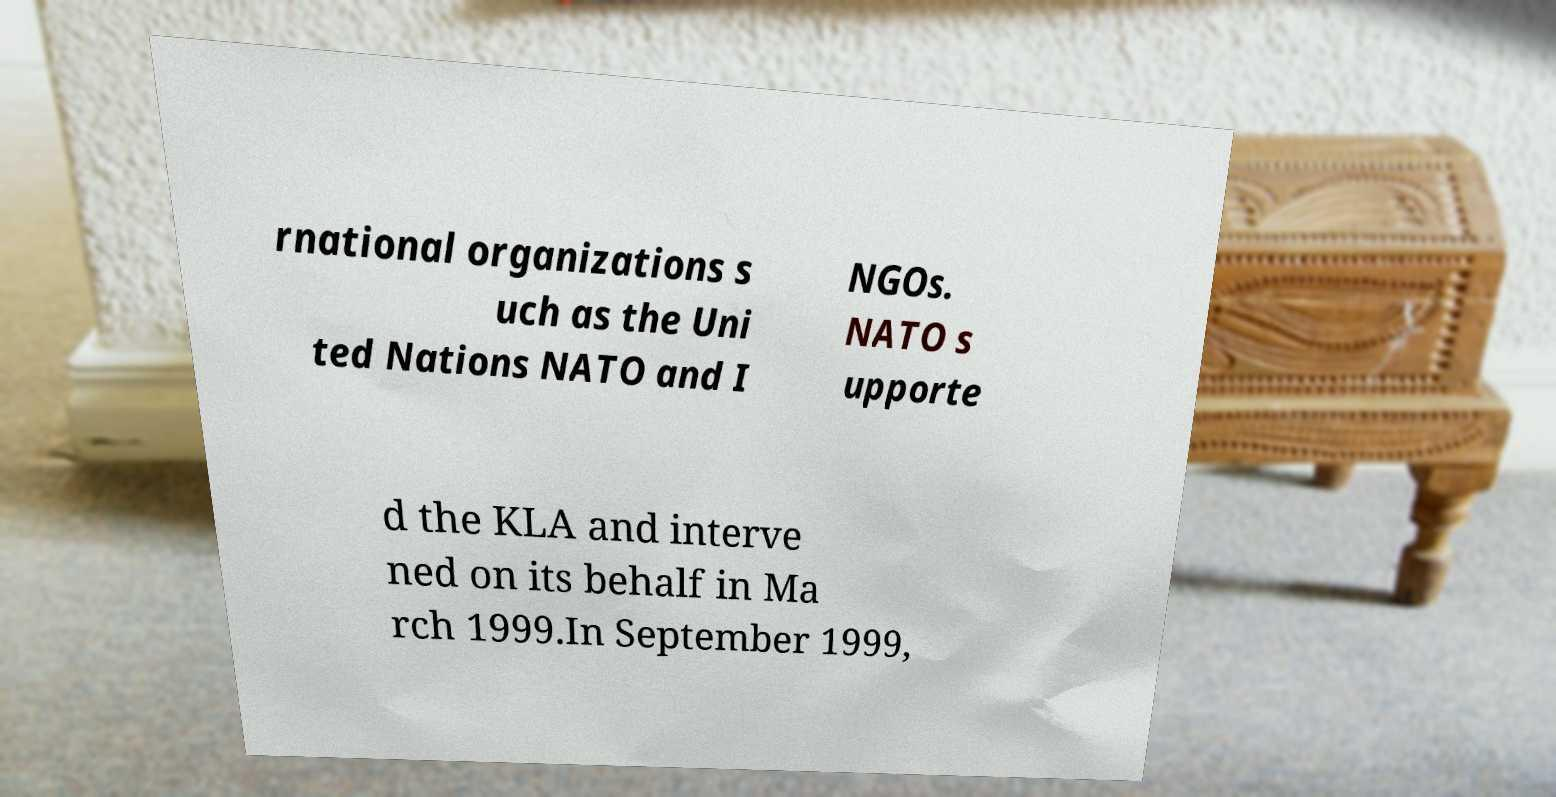I need the written content from this picture converted into text. Can you do that? rnational organizations s uch as the Uni ted Nations NATO and I NGOs. NATO s upporte d the KLA and interve ned on its behalf in Ma rch 1999.In September 1999, 